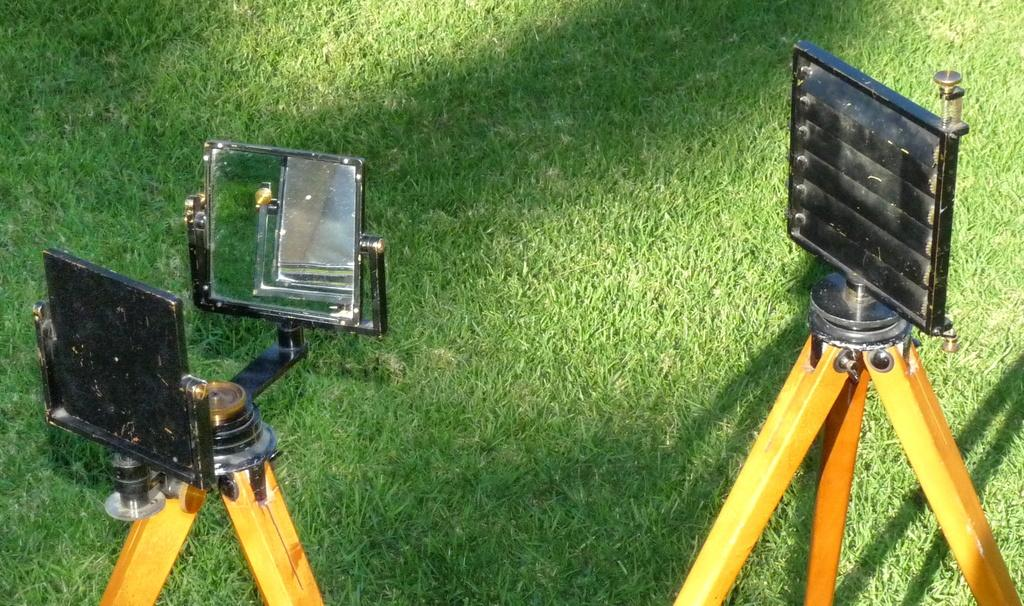How many stands are in the image? There are two stands in the image. Where are the stands located? The stands are on the ground. What type of surface is visible in the image? There is grass visible in the image. What type of night unit is visible in the image? There is no night unit present in the image. What kind of offer is being made by the stands in the image? There is no offer being made by the stands in the image; they are simply stands on the ground. 